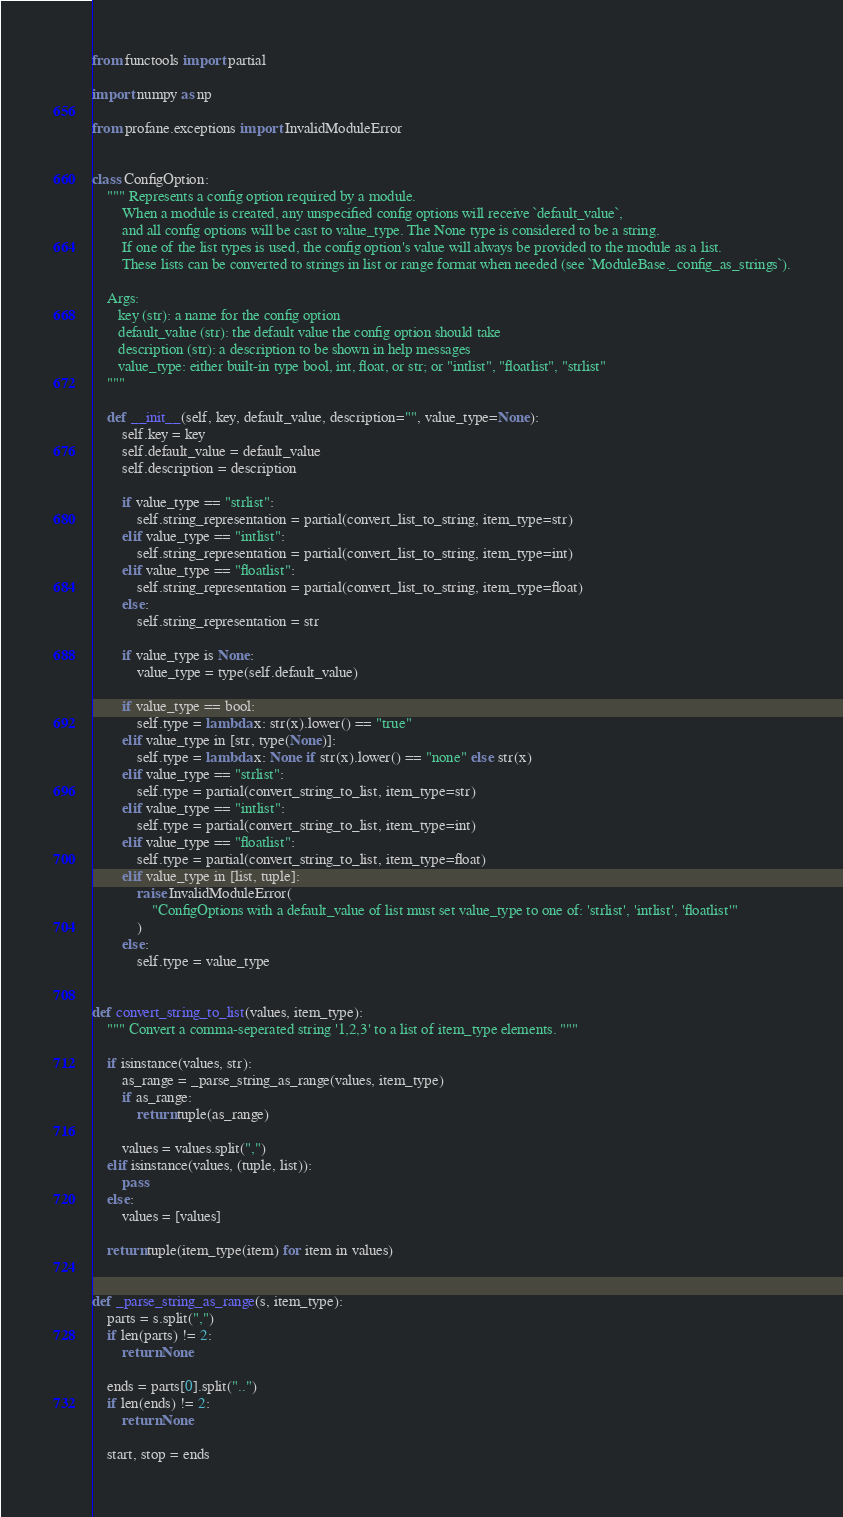Convert code to text. <code><loc_0><loc_0><loc_500><loc_500><_Python_>from functools import partial

import numpy as np

from profane.exceptions import InvalidModuleError


class ConfigOption:
    """ Represents a config option required by a module.
        When a module is created, any unspecified config options will receive `default_value`, 
        and all config options will be cast to value_type. The None type is considered to be a string.
        If one of the list types is used, the config option's value will always be provided to the module as a list.
        These lists can be converted to strings in list or range format when needed (see `ModuleBase._config_as_strings`).

    Args:
       key (str): a name for the config option
       default_value (str): the default value the config option should take
       description (str): a description to be shown in help messages
       value_type: either built-in type bool, int, float, or str; or "intlist", "floatlist", "strlist"
    """

    def __init__(self, key, default_value, description="", value_type=None):
        self.key = key
        self.default_value = default_value
        self.description = description

        if value_type == "strlist":
            self.string_representation = partial(convert_list_to_string, item_type=str)
        elif value_type == "intlist":
            self.string_representation = partial(convert_list_to_string, item_type=int)
        elif value_type == "floatlist":
            self.string_representation = partial(convert_list_to_string, item_type=float)
        else:
            self.string_representation = str

        if value_type is None:
            value_type = type(self.default_value)

        if value_type == bool:
            self.type = lambda x: str(x).lower() == "true"
        elif value_type in [str, type(None)]:
            self.type = lambda x: None if str(x).lower() == "none" else str(x)
        elif value_type == "strlist":
            self.type = partial(convert_string_to_list, item_type=str)
        elif value_type == "intlist":
            self.type = partial(convert_string_to_list, item_type=int)
        elif value_type == "floatlist":
            self.type = partial(convert_string_to_list, item_type=float)
        elif value_type in [list, tuple]:
            raise InvalidModuleError(
                "ConfigOptions with a default_value of list must set value_type to one of: 'strlist', 'intlist', 'floatlist'"
            )
        else:
            self.type = value_type


def convert_string_to_list(values, item_type):
    """ Convert a comma-seperated string '1,2,3' to a list of item_type elements. """

    if isinstance(values, str):
        as_range = _parse_string_as_range(values, item_type)
        if as_range:
            return tuple(as_range)

        values = values.split(",")
    elif isinstance(values, (tuple, list)):
        pass
    else:
        values = [values]

    return tuple(item_type(item) for item in values)


def _parse_string_as_range(s, item_type):
    parts = s.split(",")
    if len(parts) != 2:
        return None

    ends = parts[0].split("..")
    if len(ends) != 2:
        return None

    start, stop = ends</code> 